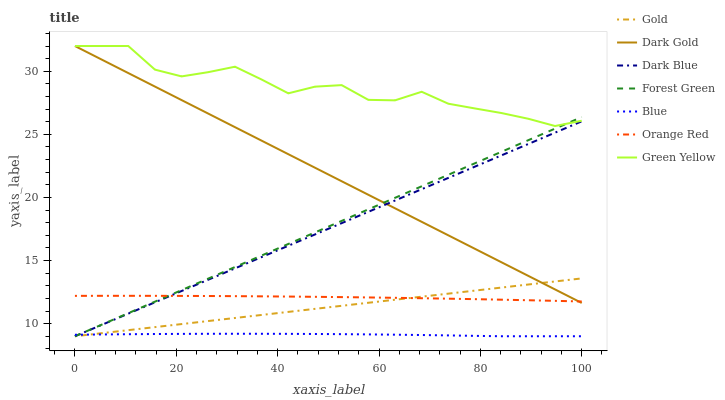Does Blue have the minimum area under the curve?
Answer yes or no. Yes. Does Green Yellow have the maximum area under the curve?
Answer yes or no. Yes. Does Gold have the minimum area under the curve?
Answer yes or no. No. Does Gold have the maximum area under the curve?
Answer yes or no. No. Is Gold the smoothest?
Answer yes or no. Yes. Is Green Yellow the roughest?
Answer yes or no. Yes. Is Dark Gold the smoothest?
Answer yes or no. No. Is Dark Gold the roughest?
Answer yes or no. No. Does Blue have the lowest value?
Answer yes or no. Yes. Does Dark Gold have the lowest value?
Answer yes or no. No. Does Green Yellow have the highest value?
Answer yes or no. Yes. Does Gold have the highest value?
Answer yes or no. No. Is Blue less than Green Yellow?
Answer yes or no. Yes. Is Green Yellow greater than Gold?
Answer yes or no. Yes. Does Dark Blue intersect Blue?
Answer yes or no. Yes. Is Dark Blue less than Blue?
Answer yes or no. No. Is Dark Blue greater than Blue?
Answer yes or no. No. Does Blue intersect Green Yellow?
Answer yes or no. No. 